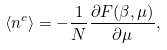Convert formula to latex. <formula><loc_0><loc_0><loc_500><loc_500>\langle n ^ { c } \rangle = - \frac { 1 } { N } \frac { \partial F ( \beta , \mu ) } { \partial \mu } ,</formula> 